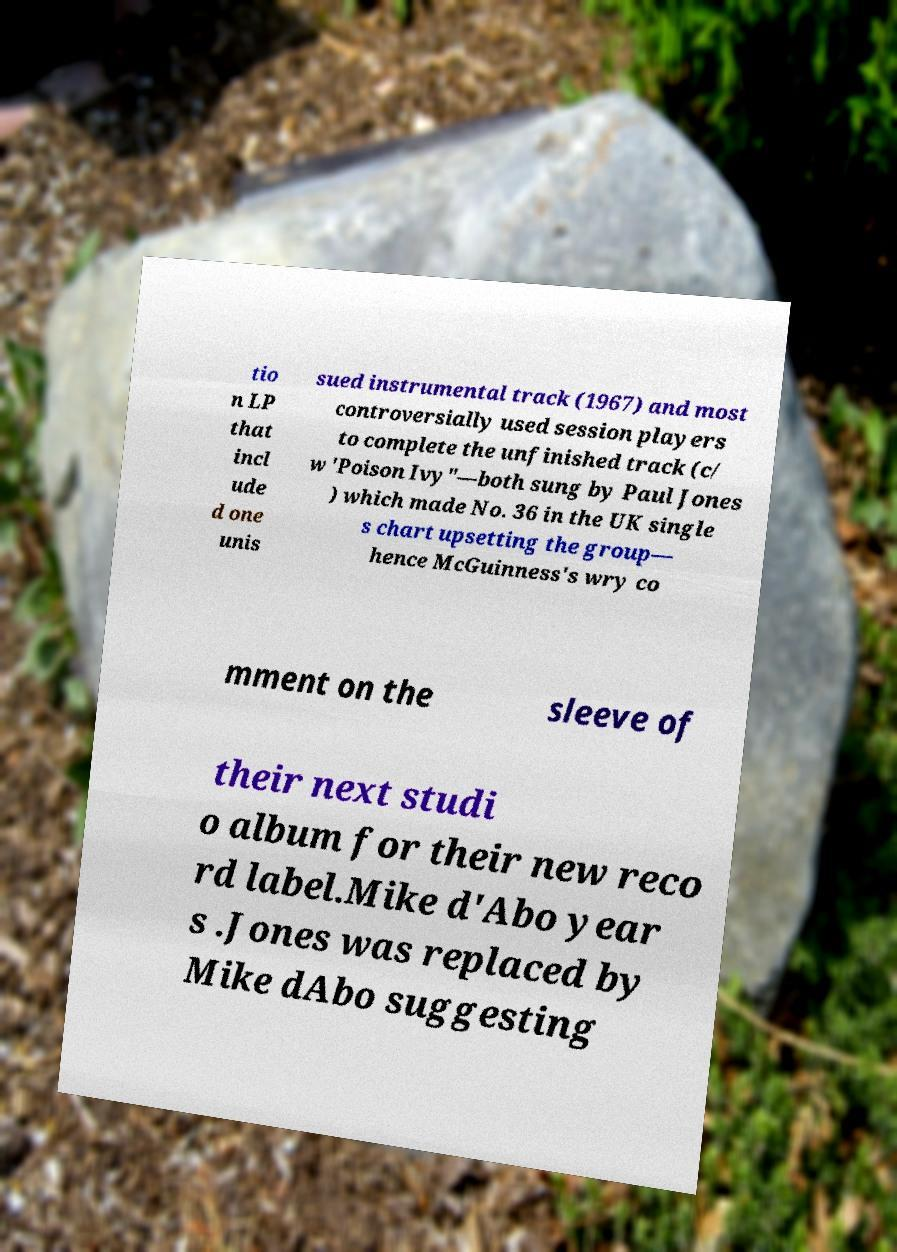For documentation purposes, I need the text within this image transcribed. Could you provide that? tio n LP that incl ude d one unis sued instrumental track (1967) and most controversially used session players to complete the unfinished track (c/ w 'Poison Ivy"—both sung by Paul Jones ) which made No. 36 in the UK single s chart upsetting the group— hence McGuinness's wry co mment on the sleeve of their next studi o album for their new reco rd label.Mike d'Abo year s .Jones was replaced by Mike dAbo suggesting 